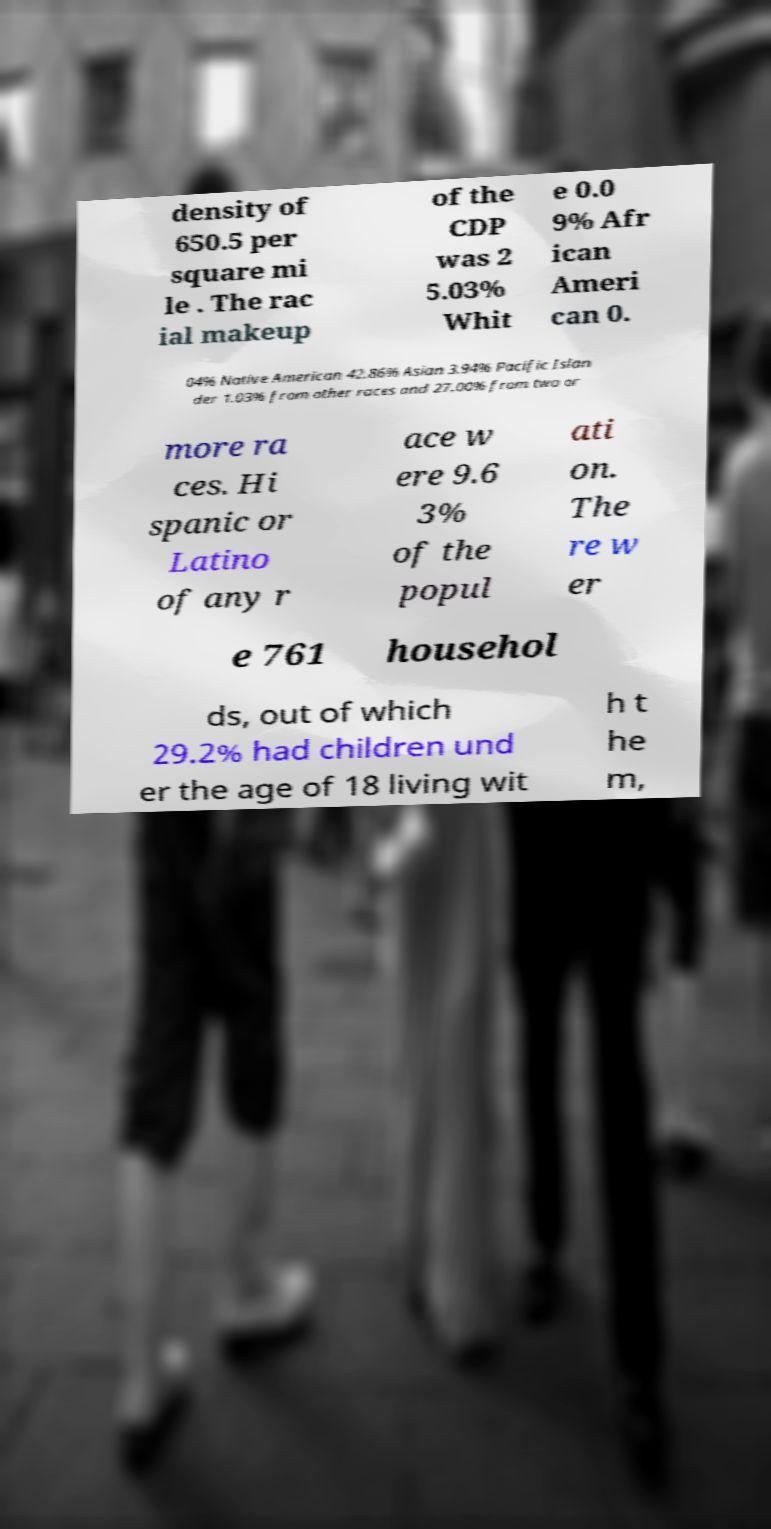Please read and relay the text visible in this image. What does it say? density of 650.5 per square mi le . The rac ial makeup of the CDP was 2 5.03% Whit e 0.0 9% Afr ican Ameri can 0. 04% Native American 42.86% Asian 3.94% Pacific Islan der 1.03% from other races and 27.00% from two or more ra ces. Hi spanic or Latino of any r ace w ere 9.6 3% of the popul ati on. The re w er e 761 househol ds, out of which 29.2% had children und er the age of 18 living wit h t he m, 